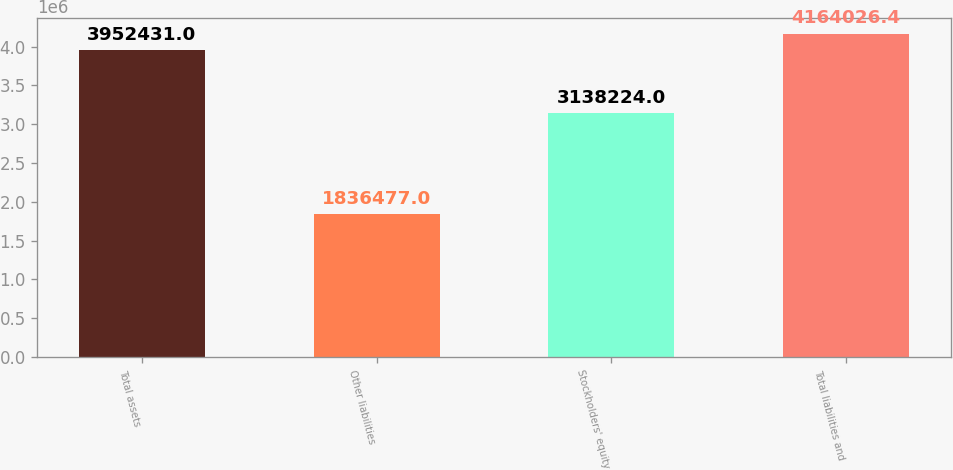Convert chart to OTSL. <chart><loc_0><loc_0><loc_500><loc_500><bar_chart><fcel>Total assets<fcel>Other liabilities<fcel>Stockholders' equity<fcel>Total liabilities and<nl><fcel>3.95243e+06<fcel>1.83648e+06<fcel>3.13822e+06<fcel>4.16403e+06<nl></chart> 